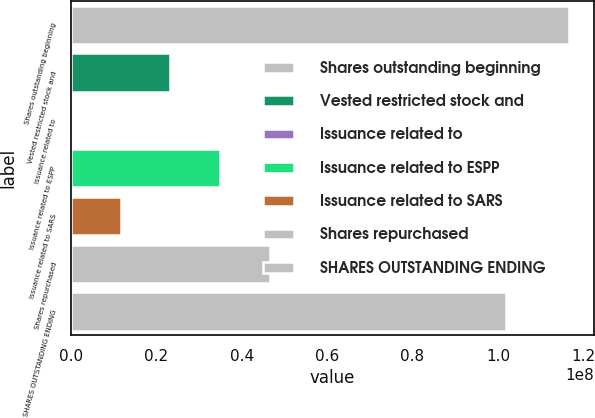Convert chart. <chart><loc_0><loc_0><loc_500><loc_500><bar_chart><fcel>Shares outstanding beginning<fcel>Vested restricted stock and<fcel>Issuance related to<fcel>Issuance related to ESPP<fcel>Issuance related to SARS<fcel>Shares repurchased<fcel>SHARES OUTSTANDING ENDING<nl><fcel>1.16649e+08<fcel>2.33297e+07<fcel>0.92<fcel>3.49946e+07<fcel>1.16649e+07<fcel>4.66595e+07<fcel>1.02e+08<nl></chart> 